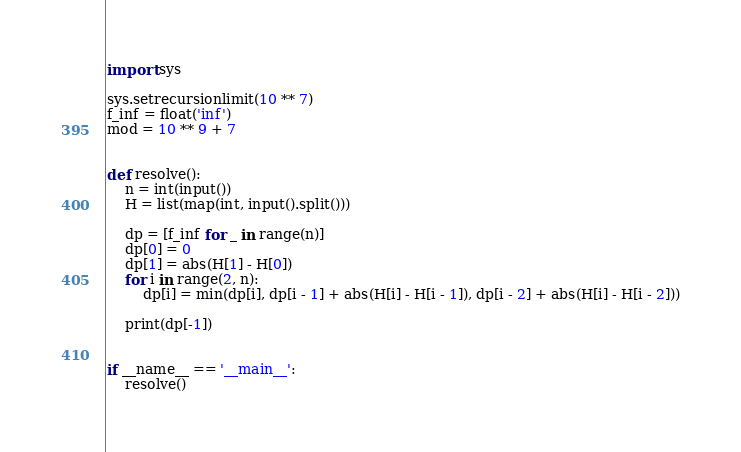Convert code to text. <code><loc_0><loc_0><loc_500><loc_500><_Python_>import sys

sys.setrecursionlimit(10 ** 7)
f_inf = float('inf')
mod = 10 ** 9 + 7


def resolve():
    n = int(input())
    H = list(map(int, input().split()))

    dp = [f_inf for _ in range(n)]
    dp[0] = 0
    dp[1] = abs(H[1] - H[0])
    for i in range(2, n):
        dp[i] = min(dp[i], dp[i - 1] + abs(H[i] - H[i - 1]), dp[i - 2] + abs(H[i] - H[i - 2]))

    print(dp[-1])


if __name__ == '__main__':
    resolve()
</code> 